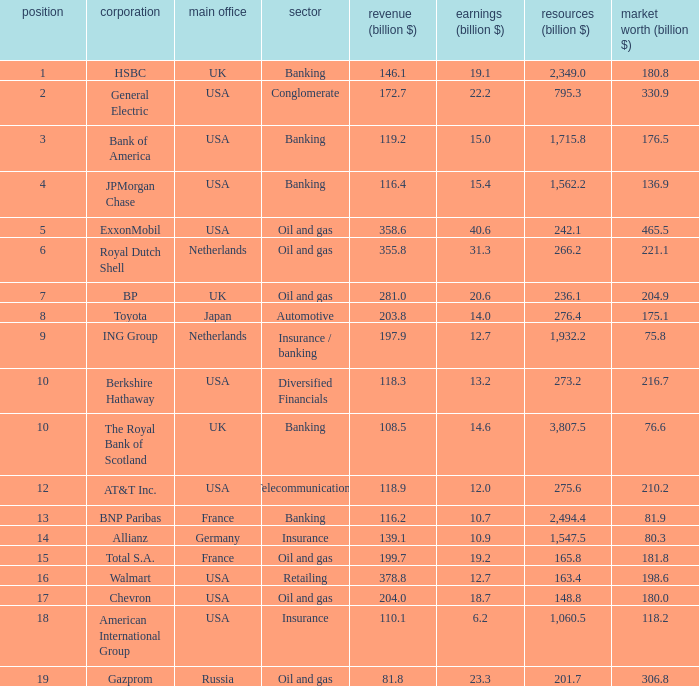What is the amount of profits in billions for companies with a market value of 204.9 billion?  20.6. 